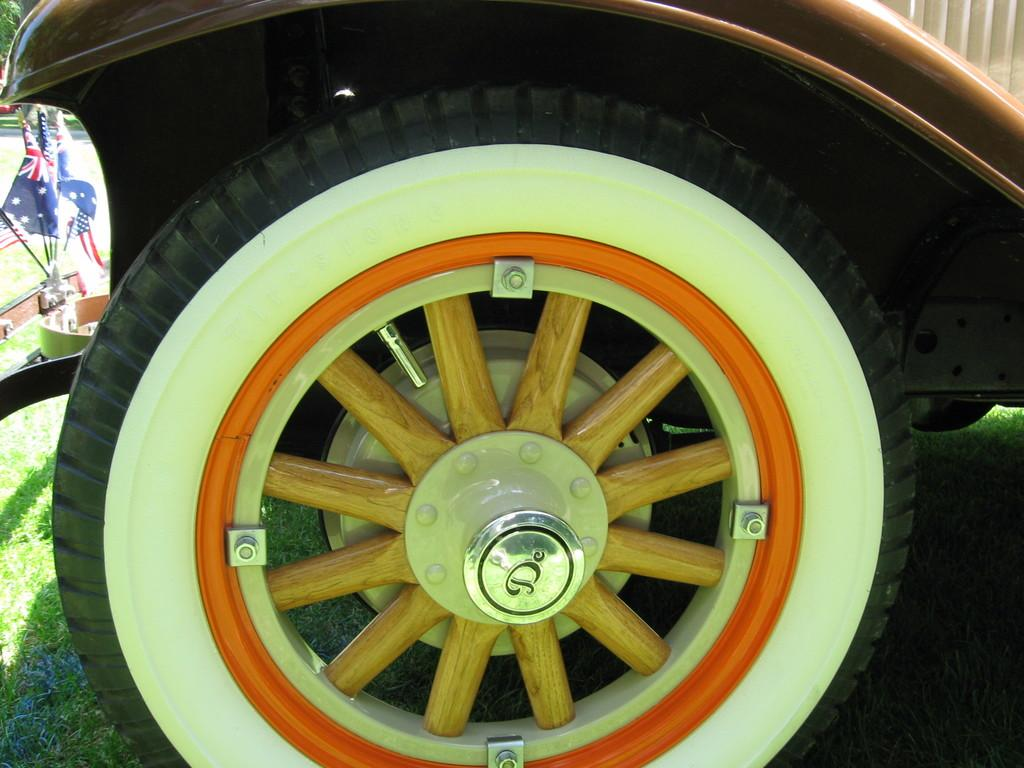What part of a vehicle can be seen in the image? There is a wheel of a vehicle in the image. What is positioned in front of the vehicle? There are flags in front of the vehicle. What type of vegetation is visible behind the flags? There are trees behind the flags. What type of milk is being poured from the wheel of the vehicle in the image? There is no milk present in the image, and the wheel of the vehicle is not pouring anything. 